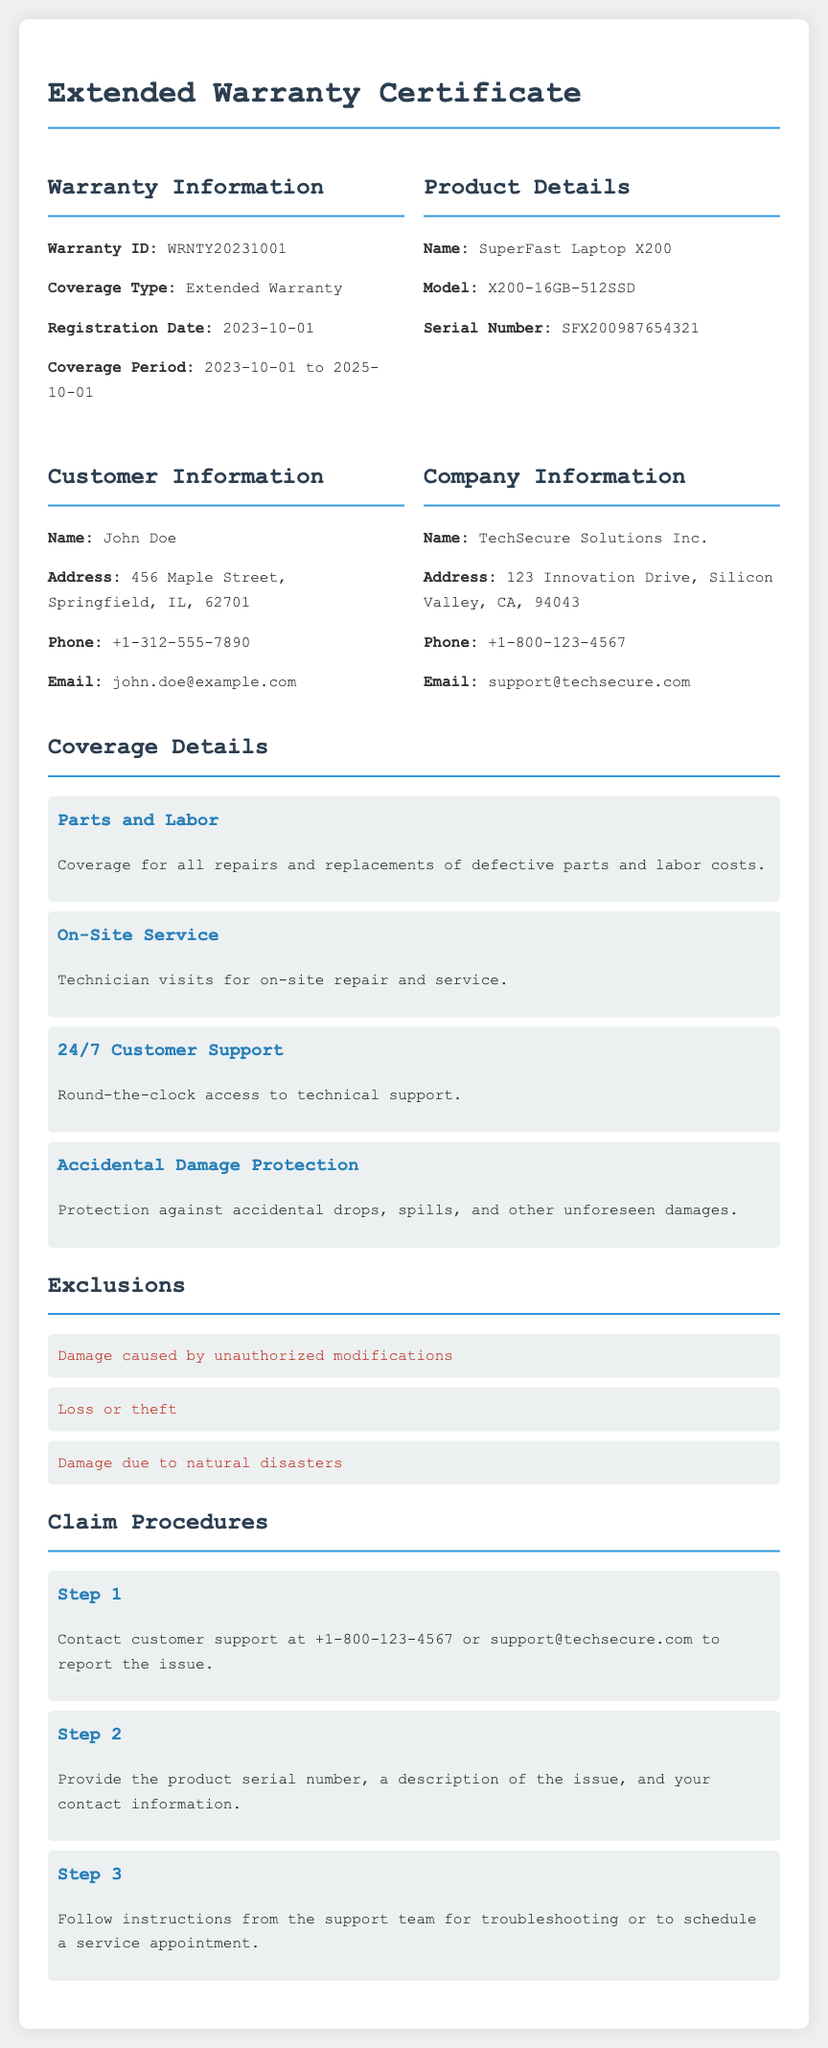What is the Warranty ID? The Warranty ID is a unique identifier for the warranty.
Answer: WRNTY20231001 What is the registration date? The registration date indicates when the warranty was registered.
Answer: 2023-10-01 Who is the customer? The customer is the individual or entity that holds the warranty.
Answer: John Doe What is the coverage period? The coverage period specifies the duration for which the warranty is valid.
Answer: 2023-10-01 to 2025-10-01 What type of equipment is covered? This question pertains to the specific equipment protected under the warranty.
Answer: SuperFast Laptop X200 What is one exclusion in the warranty? Exclusions are instances that are not covered under the warranty policy.
Answer: Loss or theft How many steps are there in the claim procedures? This indicates the number of steps a customer needs to follow to make a claim.
Answer: 3 What does "24/7 Customer Support" imply? This phrase indicates the availability of assistance regardless of the time of day.
Answer: Round-the-clock access to technical support What service is provided on-site? This refers to the type of support offered at the customer's location.
Answer: Technician visits for on-site repair and service 